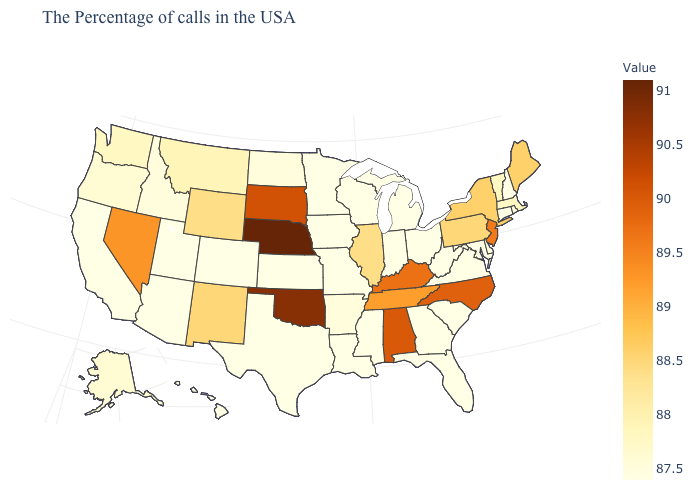Among the states that border Utah , which have the lowest value?
Quick response, please. Colorado, Arizona. Does Maine have the lowest value in the USA?
Write a very short answer. No. Among the states that border Mississippi , which have the lowest value?
Write a very short answer. Louisiana. Does Rhode Island have the lowest value in the Northeast?
Be succinct. No. Which states hav the highest value in the West?
Give a very brief answer. Nevada. Which states hav the highest value in the South?
Quick response, please. Oklahoma. 